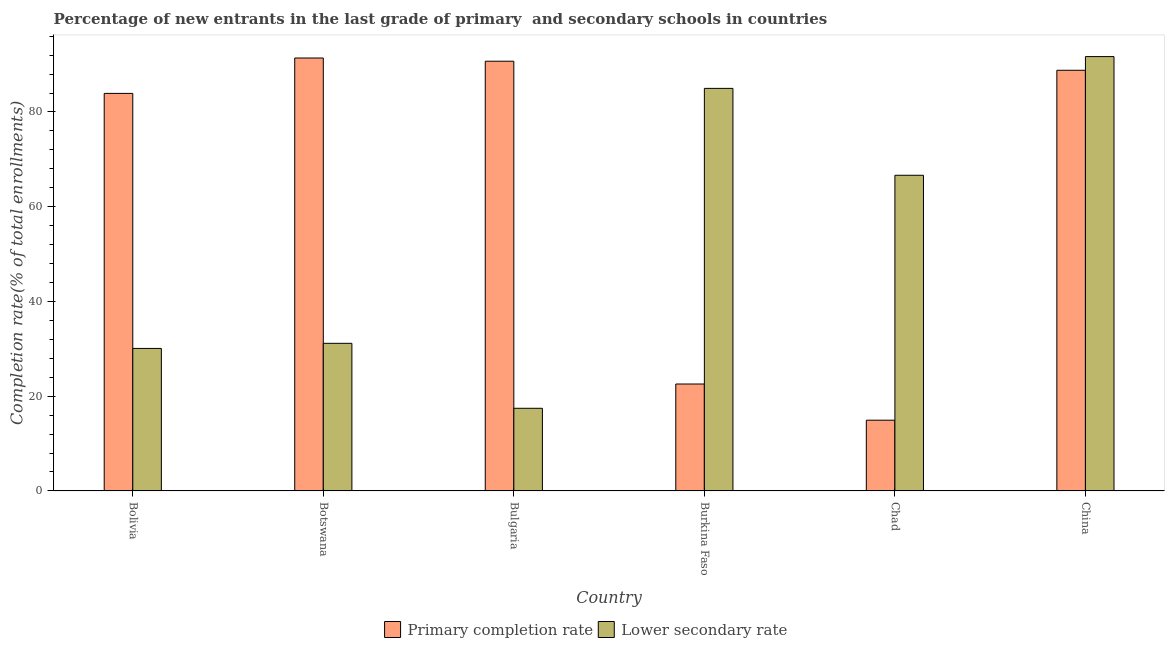How many groups of bars are there?
Your response must be concise. 6. Are the number of bars on each tick of the X-axis equal?
Provide a succinct answer. Yes. What is the label of the 4th group of bars from the left?
Provide a succinct answer. Burkina Faso. What is the completion rate in secondary schools in China?
Your answer should be compact. 91.69. Across all countries, what is the maximum completion rate in secondary schools?
Give a very brief answer. 91.69. Across all countries, what is the minimum completion rate in primary schools?
Keep it short and to the point. 14.93. In which country was the completion rate in primary schools maximum?
Give a very brief answer. Botswana. In which country was the completion rate in secondary schools minimum?
Keep it short and to the point. Bulgaria. What is the total completion rate in secondary schools in the graph?
Provide a succinct answer. 321.99. What is the difference between the completion rate in primary schools in Bulgaria and that in Burkina Faso?
Offer a very short reply. 68.14. What is the difference between the completion rate in secondary schools in Bolivia and the completion rate in primary schools in Burkina Faso?
Your response must be concise. 7.51. What is the average completion rate in primary schools per country?
Your answer should be very brief. 65.39. What is the difference between the completion rate in secondary schools and completion rate in primary schools in Botswana?
Provide a short and direct response. -60.23. In how many countries, is the completion rate in secondary schools greater than 44 %?
Offer a very short reply. 3. What is the ratio of the completion rate in primary schools in Botswana to that in Chad?
Make the answer very short. 6.12. Is the completion rate in secondary schools in Botswana less than that in Chad?
Keep it short and to the point. Yes. What is the difference between the highest and the second highest completion rate in primary schools?
Your answer should be compact. 0.68. What is the difference between the highest and the lowest completion rate in primary schools?
Your response must be concise. 76.45. What does the 1st bar from the left in Bulgaria represents?
Provide a short and direct response. Primary completion rate. What does the 2nd bar from the right in China represents?
Offer a very short reply. Primary completion rate. How many countries are there in the graph?
Offer a very short reply. 6. Are the values on the major ticks of Y-axis written in scientific E-notation?
Make the answer very short. No. Does the graph contain grids?
Your answer should be very brief. No. Where does the legend appear in the graph?
Give a very brief answer. Bottom center. What is the title of the graph?
Make the answer very short. Percentage of new entrants in the last grade of primary  and secondary schools in countries. Does "Mineral" appear as one of the legend labels in the graph?
Provide a short and direct response. No. What is the label or title of the Y-axis?
Your answer should be compact. Completion rate(% of total enrollments). What is the Completion rate(% of total enrollments) of Primary completion rate in Bolivia?
Make the answer very short. 83.92. What is the Completion rate(% of total enrollments) in Lower secondary rate in Bolivia?
Your response must be concise. 30.08. What is the Completion rate(% of total enrollments) in Primary completion rate in Botswana?
Give a very brief answer. 91.39. What is the Completion rate(% of total enrollments) of Lower secondary rate in Botswana?
Provide a short and direct response. 31.16. What is the Completion rate(% of total enrollments) of Primary completion rate in Bulgaria?
Keep it short and to the point. 90.71. What is the Completion rate(% of total enrollments) in Lower secondary rate in Bulgaria?
Keep it short and to the point. 17.45. What is the Completion rate(% of total enrollments) in Primary completion rate in Burkina Faso?
Make the answer very short. 22.57. What is the Completion rate(% of total enrollments) in Lower secondary rate in Burkina Faso?
Provide a succinct answer. 84.98. What is the Completion rate(% of total enrollments) in Primary completion rate in Chad?
Ensure brevity in your answer.  14.93. What is the Completion rate(% of total enrollments) in Lower secondary rate in Chad?
Your answer should be compact. 66.63. What is the Completion rate(% of total enrollments) in Primary completion rate in China?
Ensure brevity in your answer.  88.8. What is the Completion rate(% of total enrollments) in Lower secondary rate in China?
Your response must be concise. 91.69. Across all countries, what is the maximum Completion rate(% of total enrollments) of Primary completion rate?
Give a very brief answer. 91.39. Across all countries, what is the maximum Completion rate(% of total enrollments) of Lower secondary rate?
Your answer should be compact. 91.69. Across all countries, what is the minimum Completion rate(% of total enrollments) of Primary completion rate?
Offer a very short reply. 14.93. Across all countries, what is the minimum Completion rate(% of total enrollments) in Lower secondary rate?
Offer a terse response. 17.45. What is the total Completion rate(% of total enrollments) in Primary completion rate in the graph?
Give a very brief answer. 392.31. What is the total Completion rate(% of total enrollments) of Lower secondary rate in the graph?
Your answer should be very brief. 321.99. What is the difference between the Completion rate(% of total enrollments) in Primary completion rate in Bolivia and that in Botswana?
Your response must be concise. -7.47. What is the difference between the Completion rate(% of total enrollments) of Lower secondary rate in Bolivia and that in Botswana?
Offer a very short reply. -1.08. What is the difference between the Completion rate(% of total enrollments) in Primary completion rate in Bolivia and that in Bulgaria?
Offer a very short reply. -6.79. What is the difference between the Completion rate(% of total enrollments) of Lower secondary rate in Bolivia and that in Bulgaria?
Keep it short and to the point. 12.64. What is the difference between the Completion rate(% of total enrollments) of Primary completion rate in Bolivia and that in Burkina Faso?
Your answer should be compact. 61.34. What is the difference between the Completion rate(% of total enrollments) in Lower secondary rate in Bolivia and that in Burkina Faso?
Offer a terse response. -54.89. What is the difference between the Completion rate(% of total enrollments) in Primary completion rate in Bolivia and that in Chad?
Your response must be concise. 68.98. What is the difference between the Completion rate(% of total enrollments) of Lower secondary rate in Bolivia and that in Chad?
Provide a succinct answer. -36.55. What is the difference between the Completion rate(% of total enrollments) in Primary completion rate in Bolivia and that in China?
Your answer should be compact. -4.88. What is the difference between the Completion rate(% of total enrollments) of Lower secondary rate in Bolivia and that in China?
Your answer should be compact. -61.6. What is the difference between the Completion rate(% of total enrollments) of Primary completion rate in Botswana and that in Bulgaria?
Your response must be concise. 0.68. What is the difference between the Completion rate(% of total enrollments) of Lower secondary rate in Botswana and that in Bulgaria?
Make the answer very short. 13.71. What is the difference between the Completion rate(% of total enrollments) in Primary completion rate in Botswana and that in Burkina Faso?
Make the answer very short. 68.81. What is the difference between the Completion rate(% of total enrollments) in Lower secondary rate in Botswana and that in Burkina Faso?
Your answer should be very brief. -53.81. What is the difference between the Completion rate(% of total enrollments) in Primary completion rate in Botswana and that in Chad?
Ensure brevity in your answer.  76.45. What is the difference between the Completion rate(% of total enrollments) in Lower secondary rate in Botswana and that in Chad?
Provide a succinct answer. -35.47. What is the difference between the Completion rate(% of total enrollments) in Primary completion rate in Botswana and that in China?
Make the answer very short. 2.59. What is the difference between the Completion rate(% of total enrollments) in Lower secondary rate in Botswana and that in China?
Offer a very short reply. -60.53. What is the difference between the Completion rate(% of total enrollments) of Primary completion rate in Bulgaria and that in Burkina Faso?
Your answer should be compact. 68.14. What is the difference between the Completion rate(% of total enrollments) in Lower secondary rate in Bulgaria and that in Burkina Faso?
Make the answer very short. -67.53. What is the difference between the Completion rate(% of total enrollments) of Primary completion rate in Bulgaria and that in Chad?
Your response must be concise. 75.78. What is the difference between the Completion rate(% of total enrollments) of Lower secondary rate in Bulgaria and that in Chad?
Your response must be concise. -49.19. What is the difference between the Completion rate(% of total enrollments) of Primary completion rate in Bulgaria and that in China?
Your response must be concise. 1.91. What is the difference between the Completion rate(% of total enrollments) of Lower secondary rate in Bulgaria and that in China?
Your answer should be very brief. -74.24. What is the difference between the Completion rate(% of total enrollments) in Primary completion rate in Burkina Faso and that in Chad?
Your response must be concise. 7.64. What is the difference between the Completion rate(% of total enrollments) in Lower secondary rate in Burkina Faso and that in Chad?
Your response must be concise. 18.34. What is the difference between the Completion rate(% of total enrollments) in Primary completion rate in Burkina Faso and that in China?
Ensure brevity in your answer.  -66.23. What is the difference between the Completion rate(% of total enrollments) of Lower secondary rate in Burkina Faso and that in China?
Your response must be concise. -6.71. What is the difference between the Completion rate(% of total enrollments) of Primary completion rate in Chad and that in China?
Your answer should be very brief. -73.87. What is the difference between the Completion rate(% of total enrollments) of Lower secondary rate in Chad and that in China?
Offer a terse response. -25.05. What is the difference between the Completion rate(% of total enrollments) of Primary completion rate in Bolivia and the Completion rate(% of total enrollments) of Lower secondary rate in Botswana?
Make the answer very short. 52.76. What is the difference between the Completion rate(% of total enrollments) in Primary completion rate in Bolivia and the Completion rate(% of total enrollments) in Lower secondary rate in Bulgaria?
Your response must be concise. 66.47. What is the difference between the Completion rate(% of total enrollments) of Primary completion rate in Bolivia and the Completion rate(% of total enrollments) of Lower secondary rate in Burkina Faso?
Your answer should be very brief. -1.06. What is the difference between the Completion rate(% of total enrollments) of Primary completion rate in Bolivia and the Completion rate(% of total enrollments) of Lower secondary rate in Chad?
Your response must be concise. 17.28. What is the difference between the Completion rate(% of total enrollments) of Primary completion rate in Bolivia and the Completion rate(% of total enrollments) of Lower secondary rate in China?
Provide a succinct answer. -7.77. What is the difference between the Completion rate(% of total enrollments) in Primary completion rate in Botswana and the Completion rate(% of total enrollments) in Lower secondary rate in Bulgaria?
Offer a very short reply. 73.94. What is the difference between the Completion rate(% of total enrollments) in Primary completion rate in Botswana and the Completion rate(% of total enrollments) in Lower secondary rate in Burkina Faso?
Give a very brief answer. 6.41. What is the difference between the Completion rate(% of total enrollments) in Primary completion rate in Botswana and the Completion rate(% of total enrollments) in Lower secondary rate in Chad?
Offer a very short reply. 24.75. What is the difference between the Completion rate(% of total enrollments) of Primary completion rate in Botswana and the Completion rate(% of total enrollments) of Lower secondary rate in China?
Provide a short and direct response. -0.3. What is the difference between the Completion rate(% of total enrollments) of Primary completion rate in Bulgaria and the Completion rate(% of total enrollments) of Lower secondary rate in Burkina Faso?
Keep it short and to the point. 5.73. What is the difference between the Completion rate(% of total enrollments) of Primary completion rate in Bulgaria and the Completion rate(% of total enrollments) of Lower secondary rate in Chad?
Offer a terse response. 24.07. What is the difference between the Completion rate(% of total enrollments) in Primary completion rate in Bulgaria and the Completion rate(% of total enrollments) in Lower secondary rate in China?
Provide a short and direct response. -0.98. What is the difference between the Completion rate(% of total enrollments) in Primary completion rate in Burkina Faso and the Completion rate(% of total enrollments) in Lower secondary rate in Chad?
Ensure brevity in your answer.  -44.06. What is the difference between the Completion rate(% of total enrollments) in Primary completion rate in Burkina Faso and the Completion rate(% of total enrollments) in Lower secondary rate in China?
Offer a terse response. -69.11. What is the difference between the Completion rate(% of total enrollments) of Primary completion rate in Chad and the Completion rate(% of total enrollments) of Lower secondary rate in China?
Provide a short and direct response. -76.75. What is the average Completion rate(% of total enrollments) of Primary completion rate per country?
Your answer should be compact. 65.39. What is the average Completion rate(% of total enrollments) in Lower secondary rate per country?
Make the answer very short. 53.66. What is the difference between the Completion rate(% of total enrollments) of Primary completion rate and Completion rate(% of total enrollments) of Lower secondary rate in Bolivia?
Your response must be concise. 53.83. What is the difference between the Completion rate(% of total enrollments) in Primary completion rate and Completion rate(% of total enrollments) in Lower secondary rate in Botswana?
Ensure brevity in your answer.  60.23. What is the difference between the Completion rate(% of total enrollments) of Primary completion rate and Completion rate(% of total enrollments) of Lower secondary rate in Bulgaria?
Offer a terse response. 73.26. What is the difference between the Completion rate(% of total enrollments) in Primary completion rate and Completion rate(% of total enrollments) in Lower secondary rate in Burkina Faso?
Your answer should be compact. -62.4. What is the difference between the Completion rate(% of total enrollments) in Primary completion rate and Completion rate(% of total enrollments) in Lower secondary rate in Chad?
Offer a terse response. -51.7. What is the difference between the Completion rate(% of total enrollments) in Primary completion rate and Completion rate(% of total enrollments) in Lower secondary rate in China?
Your answer should be compact. -2.89. What is the ratio of the Completion rate(% of total enrollments) in Primary completion rate in Bolivia to that in Botswana?
Provide a short and direct response. 0.92. What is the ratio of the Completion rate(% of total enrollments) of Lower secondary rate in Bolivia to that in Botswana?
Offer a terse response. 0.97. What is the ratio of the Completion rate(% of total enrollments) of Primary completion rate in Bolivia to that in Bulgaria?
Offer a very short reply. 0.93. What is the ratio of the Completion rate(% of total enrollments) of Lower secondary rate in Bolivia to that in Bulgaria?
Give a very brief answer. 1.72. What is the ratio of the Completion rate(% of total enrollments) of Primary completion rate in Bolivia to that in Burkina Faso?
Your answer should be compact. 3.72. What is the ratio of the Completion rate(% of total enrollments) in Lower secondary rate in Bolivia to that in Burkina Faso?
Keep it short and to the point. 0.35. What is the ratio of the Completion rate(% of total enrollments) in Primary completion rate in Bolivia to that in Chad?
Ensure brevity in your answer.  5.62. What is the ratio of the Completion rate(% of total enrollments) in Lower secondary rate in Bolivia to that in Chad?
Keep it short and to the point. 0.45. What is the ratio of the Completion rate(% of total enrollments) of Primary completion rate in Bolivia to that in China?
Give a very brief answer. 0.94. What is the ratio of the Completion rate(% of total enrollments) in Lower secondary rate in Bolivia to that in China?
Give a very brief answer. 0.33. What is the ratio of the Completion rate(% of total enrollments) of Primary completion rate in Botswana to that in Bulgaria?
Give a very brief answer. 1.01. What is the ratio of the Completion rate(% of total enrollments) in Lower secondary rate in Botswana to that in Bulgaria?
Your response must be concise. 1.79. What is the ratio of the Completion rate(% of total enrollments) of Primary completion rate in Botswana to that in Burkina Faso?
Make the answer very short. 4.05. What is the ratio of the Completion rate(% of total enrollments) of Lower secondary rate in Botswana to that in Burkina Faso?
Give a very brief answer. 0.37. What is the ratio of the Completion rate(% of total enrollments) in Primary completion rate in Botswana to that in Chad?
Offer a terse response. 6.12. What is the ratio of the Completion rate(% of total enrollments) of Lower secondary rate in Botswana to that in Chad?
Provide a short and direct response. 0.47. What is the ratio of the Completion rate(% of total enrollments) in Primary completion rate in Botswana to that in China?
Provide a short and direct response. 1.03. What is the ratio of the Completion rate(% of total enrollments) of Lower secondary rate in Botswana to that in China?
Your answer should be compact. 0.34. What is the ratio of the Completion rate(% of total enrollments) in Primary completion rate in Bulgaria to that in Burkina Faso?
Your answer should be compact. 4.02. What is the ratio of the Completion rate(% of total enrollments) in Lower secondary rate in Bulgaria to that in Burkina Faso?
Ensure brevity in your answer.  0.21. What is the ratio of the Completion rate(% of total enrollments) of Primary completion rate in Bulgaria to that in Chad?
Provide a short and direct response. 6.07. What is the ratio of the Completion rate(% of total enrollments) of Lower secondary rate in Bulgaria to that in Chad?
Provide a succinct answer. 0.26. What is the ratio of the Completion rate(% of total enrollments) in Primary completion rate in Bulgaria to that in China?
Keep it short and to the point. 1.02. What is the ratio of the Completion rate(% of total enrollments) of Lower secondary rate in Bulgaria to that in China?
Your answer should be very brief. 0.19. What is the ratio of the Completion rate(% of total enrollments) of Primary completion rate in Burkina Faso to that in Chad?
Provide a succinct answer. 1.51. What is the ratio of the Completion rate(% of total enrollments) of Lower secondary rate in Burkina Faso to that in Chad?
Your answer should be very brief. 1.28. What is the ratio of the Completion rate(% of total enrollments) in Primary completion rate in Burkina Faso to that in China?
Ensure brevity in your answer.  0.25. What is the ratio of the Completion rate(% of total enrollments) of Lower secondary rate in Burkina Faso to that in China?
Make the answer very short. 0.93. What is the ratio of the Completion rate(% of total enrollments) of Primary completion rate in Chad to that in China?
Make the answer very short. 0.17. What is the ratio of the Completion rate(% of total enrollments) in Lower secondary rate in Chad to that in China?
Make the answer very short. 0.73. What is the difference between the highest and the second highest Completion rate(% of total enrollments) in Primary completion rate?
Offer a terse response. 0.68. What is the difference between the highest and the second highest Completion rate(% of total enrollments) of Lower secondary rate?
Your answer should be very brief. 6.71. What is the difference between the highest and the lowest Completion rate(% of total enrollments) of Primary completion rate?
Offer a terse response. 76.45. What is the difference between the highest and the lowest Completion rate(% of total enrollments) of Lower secondary rate?
Keep it short and to the point. 74.24. 